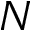Convert formula to latex. <formula><loc_0><loc_0><loc_500><loc_500>N</formula> 